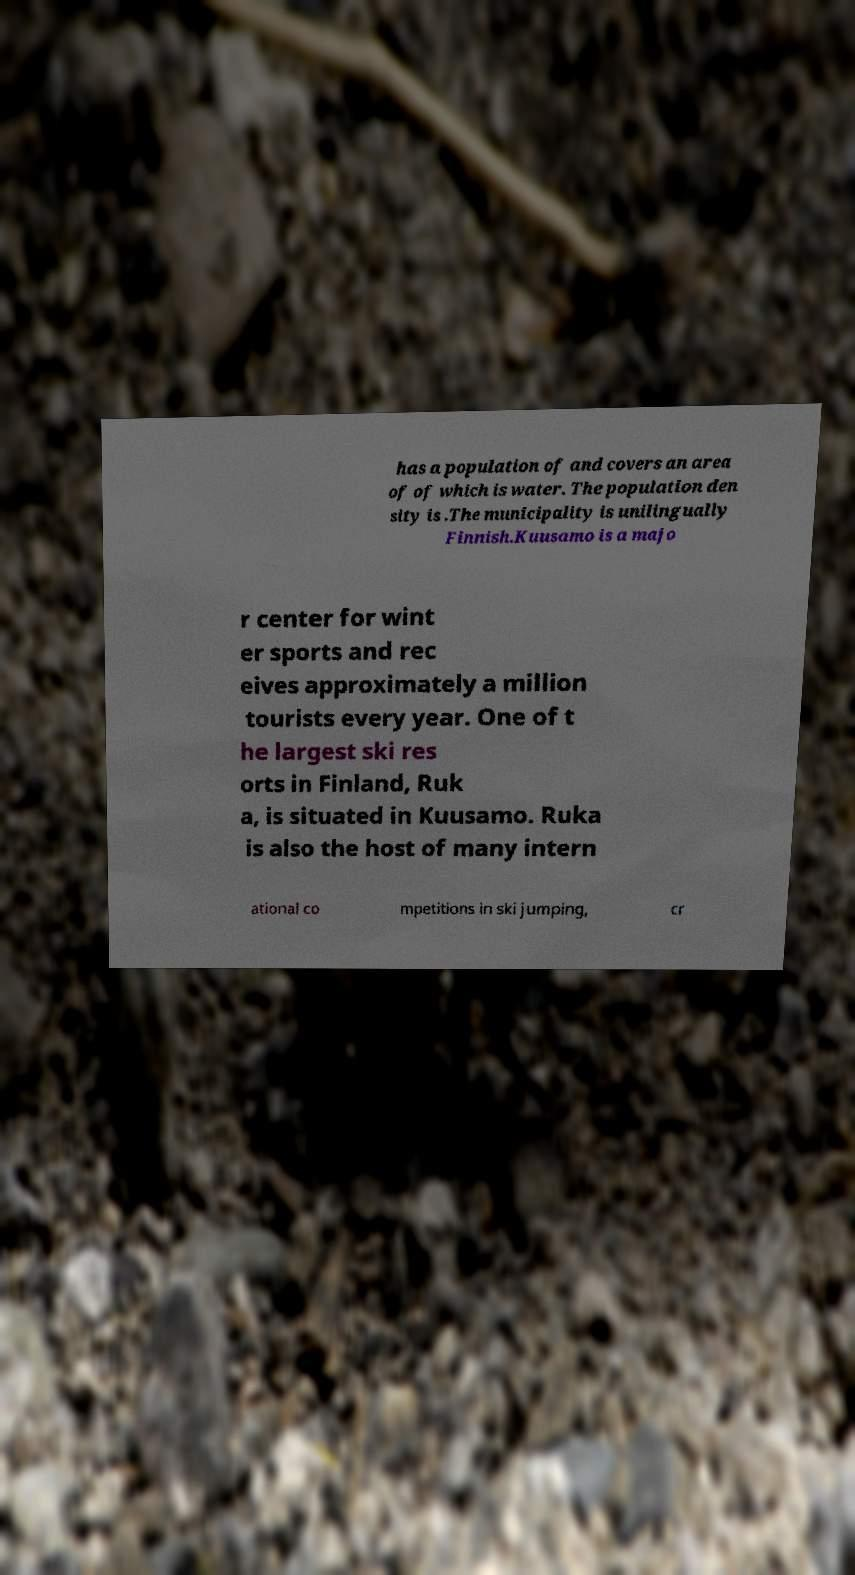I need the written content from this picture converted into text. Can you do that? has a population of and covers an area of of which is water. The population den sity is .The municipality is unilingually Finnish.Kuusamo is a majo r center for wint er sports and rec eives approximately a million tourists every year. One of t he largest ski res orts in Finland, Ruk a, is situated in Kuusamo. Ruka is also the host of many intern ational co mpetitions in ski jumping, cr 